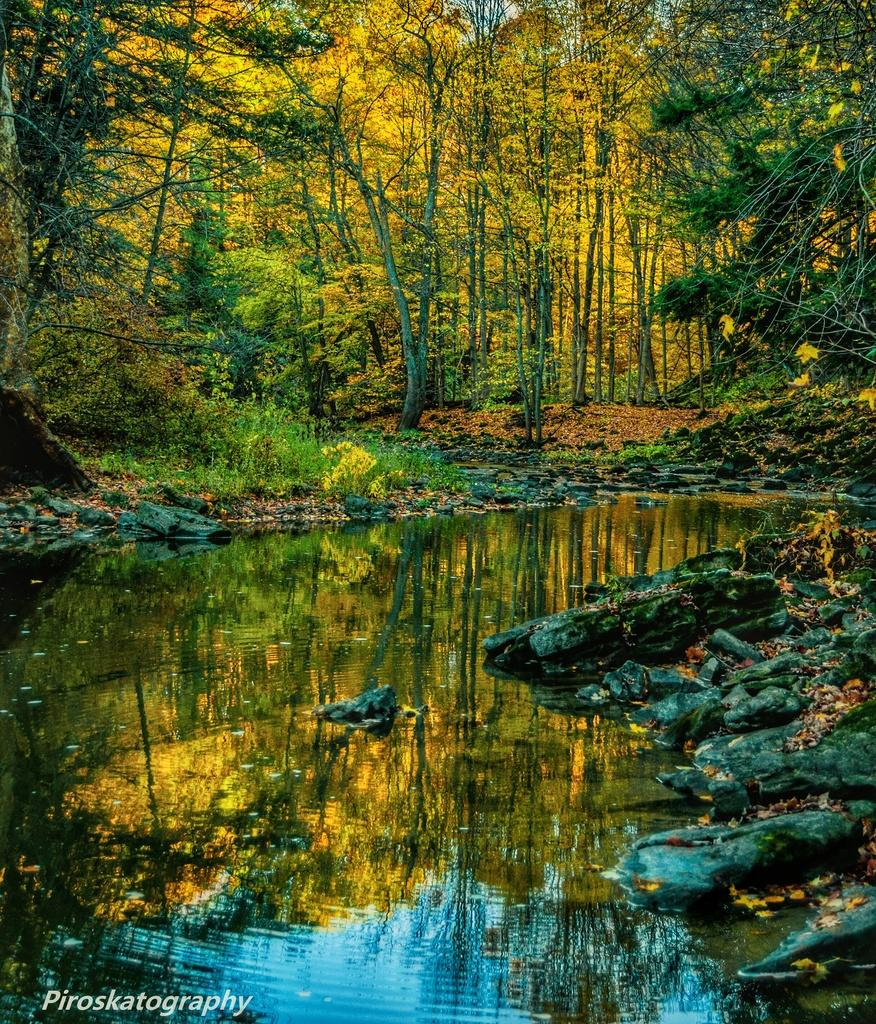What type of natural environment is depicted in the image? The image features trees and a lake, indicating a natural setting. Can you describe the location of the lake in relation to the trees? The lake is located in the middle of the trees in the image. Is there any text present in the image? Yes, there is some text at the bottom of the image. What is the weight of the bead that is hanging from the tree in the image? There is no bead hanging from a tree in the image, so it is not possible to determine its weight. 